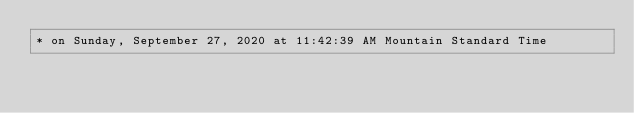Convert code to text. <code><loc_0><loc_0><loc_500><loc_500><_C_>* on Sunday, September 27, 2020 at 11:42:39 AM Mountain Standard Time</code> 